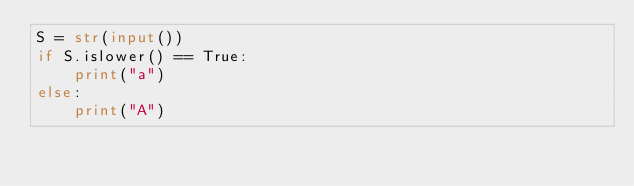Convert code to text. <code><loc_0><loc_0><loc_500><loc_500><_Python_>S = str(input())
if S.islower() == True:
    print("a")
else:
    print("A") </code> 